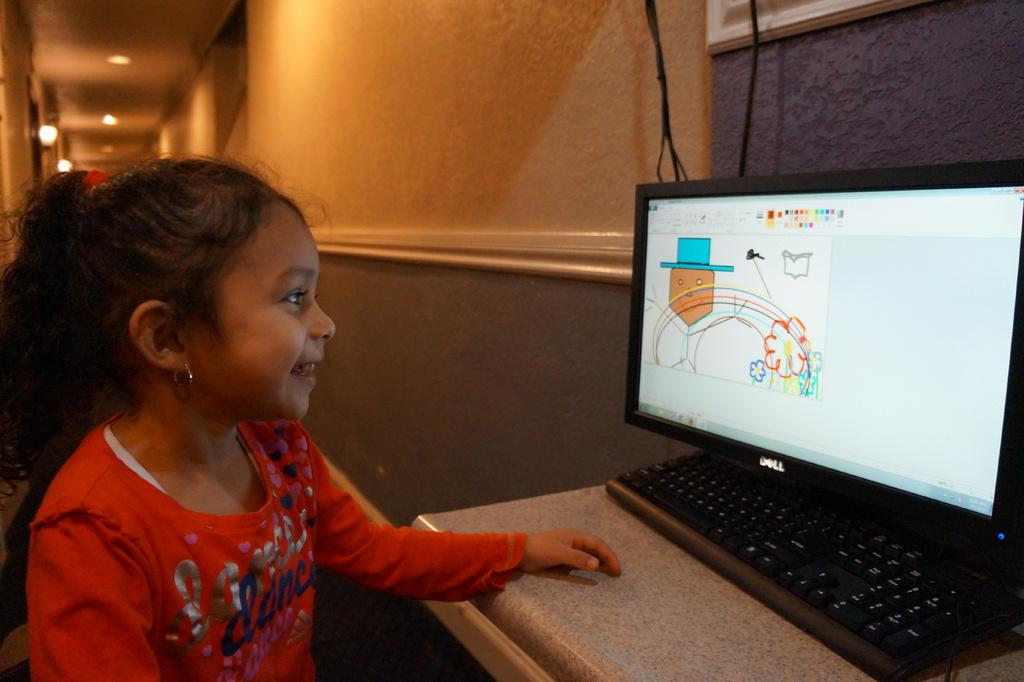<image>
Give a short and clear explanation of the subsequent image. a girl with a red shirt reading DANCE looking at a computer monitor 